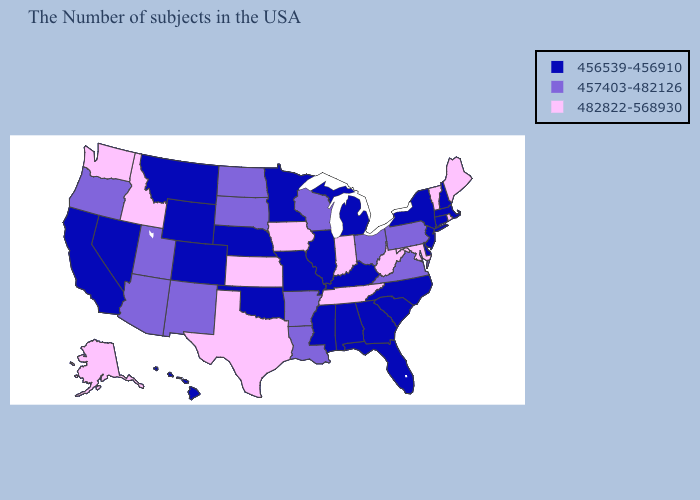What is the value of Arkansas?
Give a very brief answer. 457403-482126. What is the lowest value in the Northeast?
Short answer required. 456539-456910. What is the value of Illinois?
Give a very brief answer. 456539-456910. Name the states that have a value in the range 482822-568930?
Concise answer only. Maine, Rhode Island, Vermont, Maryland, West Virginia, Indiana, Tennessee, Iowa, Kansas, Texas, Idaho, Washington, Alaska. Does Maine have the highest value in the Northeast?
Give a very brief answer. Yes. What is the value of New Jersey?
Be succinct. 456539-456910. What is the value of Kentucky?
Answer briefly. 456539-456910. What is the lowest value in the USA?
Short answer required. 456539-456910. What is the value of Ohio?
Answer briefly. 457403-482126. Does Missouri have the highest value in the USA?
Give a very brief answer. No. Among the states that border Alabama , does Tennessee have the highest value?
Keep it brief. Yes. Which states have the lowest value in the USA?
Give a very brief answer. Massachusetts, New Hampshire, Connecticut, New York, New Jersey, Delaware, North Carolina, South Carolina, Florida, Georgia, Michigan, Kentucky, Alabama, Illinois, Mississippi, Missouri, Minnesota, Nebraska, Oklahoma, Wyoming, Colorado, Montana, Nevada, California, Hawaii. Name the states that have a value in the range 482822-568930?
Concise answer only. Maine, Rhode Island, Vermont, Maryland, West Virginia, Indiana, Tennessee, Iowa, Kansas, Texas, Idaho, Washington, Alaska. Does Idaho have the highest value in the West?
Short answer required. Yes. Does Nevada have a higher value than North Carolina?
Concise answer only. No. 